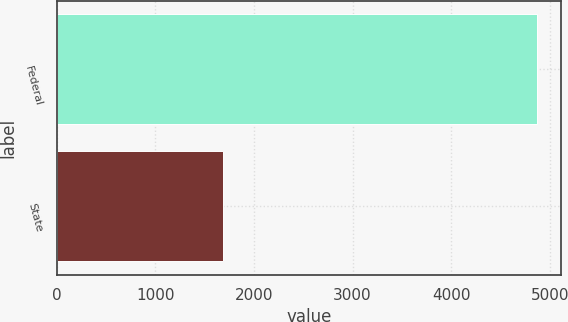<chart> <loc_0><loc_0><loc_500><loc_500><bar_chart><fcel>Federal<fcel>State<nl><fcel>4874<fcel>1688<nl></chart> 